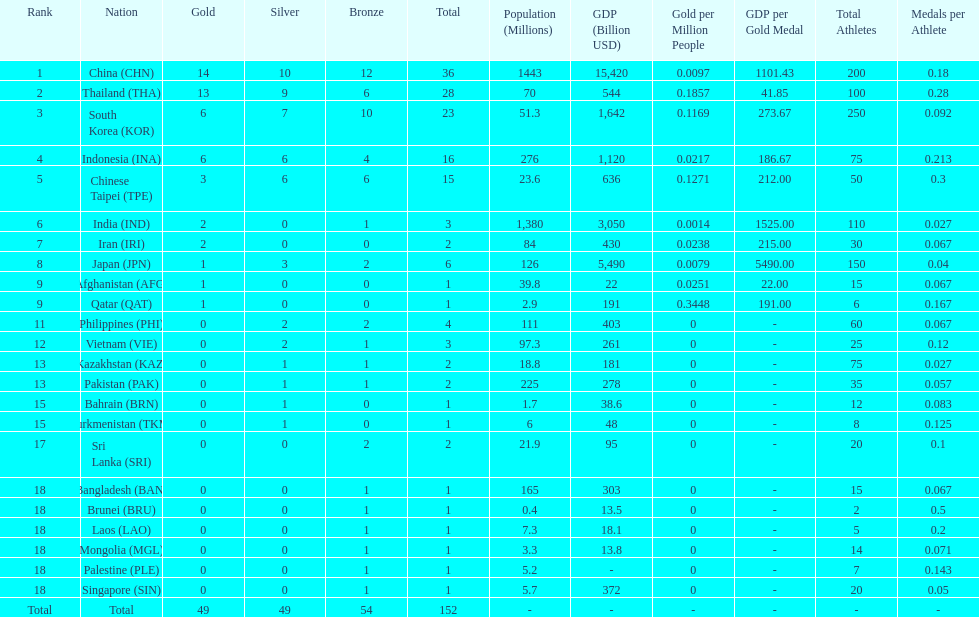What is the total number of nations that participated in the beach games of 2012? 23. 